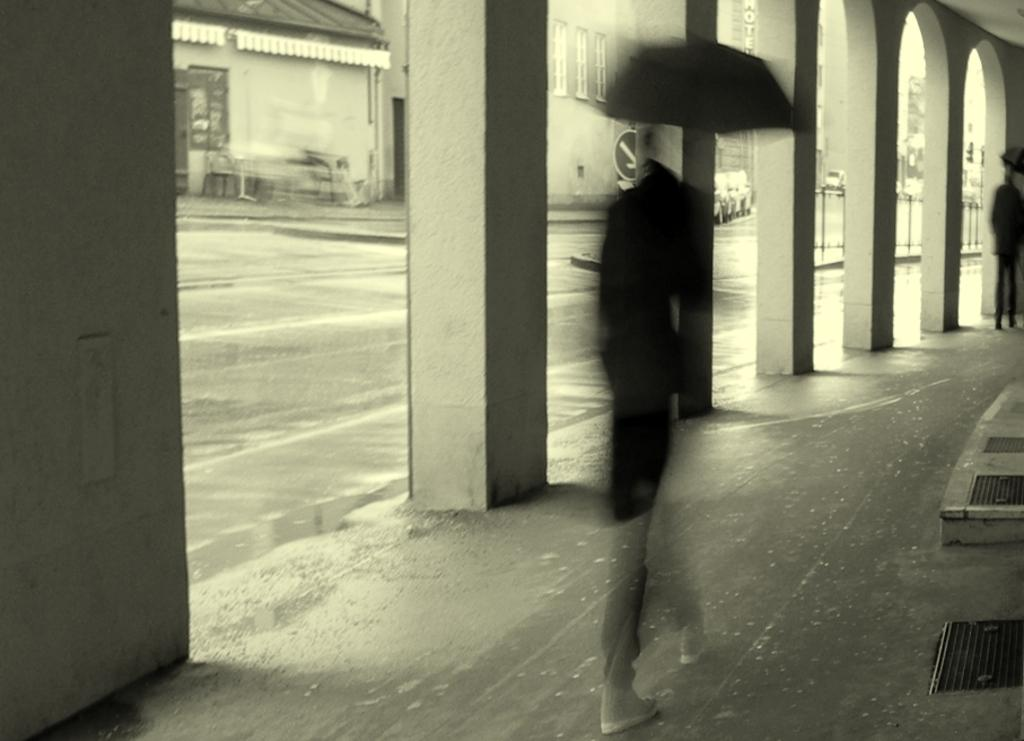What are the people in the image doing? The people in the image are walking. What are the people holding while walking? The people are holding umbrellas. What can be seen in the background of the image? There are pillars, a road, and other buildings visible in the background of the image. What type of activity is the doll participating in with the baseball players in the image? There is no doll or baseball players present in the image. 